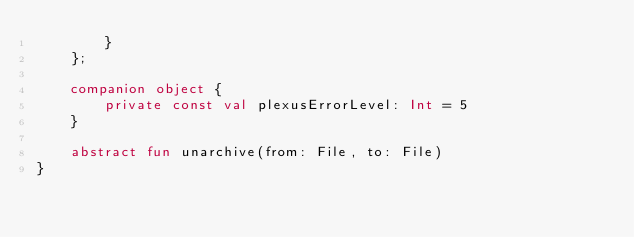<code> <loc_0><loc_0><loc_500><loc_500><_Kotlin_>        }
    };

    companion object {
        private const val plexusErrorLevel: Int = 5
    }

    abstract fun unarchive(from: File, to: File)
}
</code> 